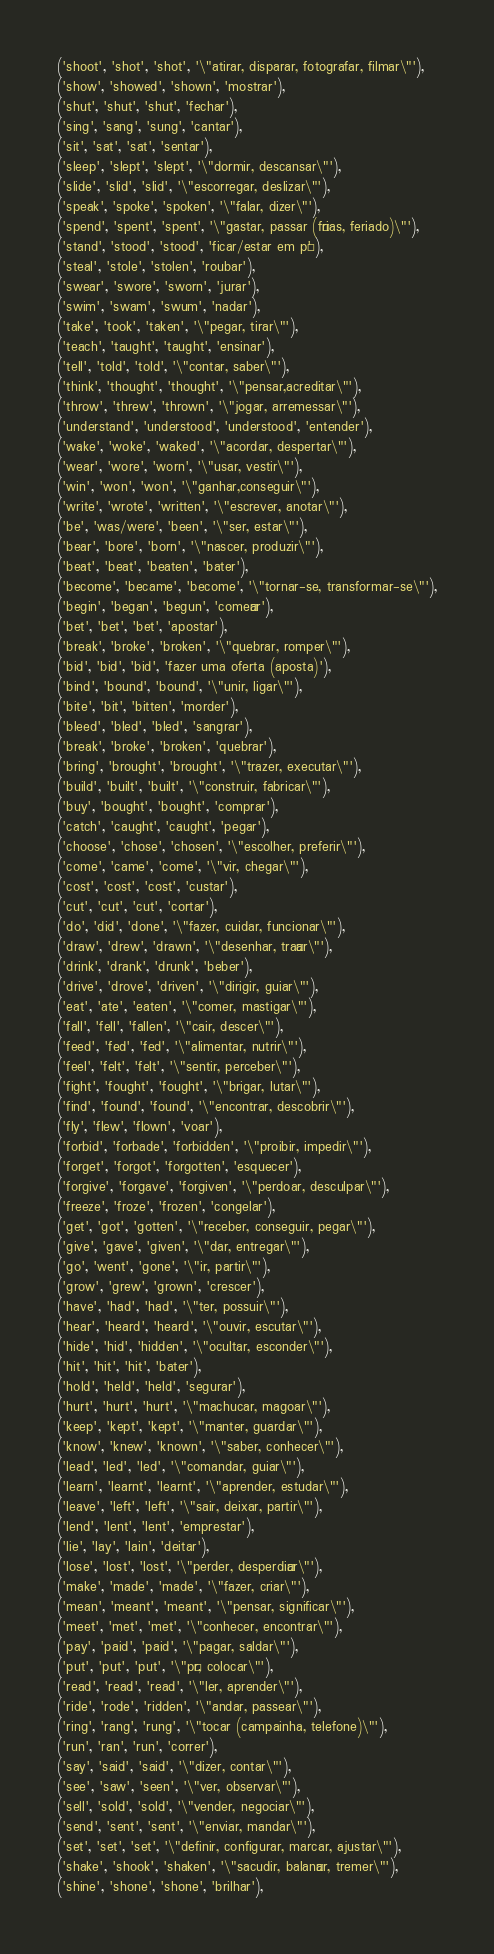<code> <loc_0><loc_0><loc_500><loc_500><_SQL_>('shoot', 'shot', 'shot', '\"atirar, disparar, fotografar, filmar\"'),
('show', 'showed', 'shown', 'mostrar'),
('shut', 'shut', 'shut', 'fechar'),
('sing', 'sang', 'sung', 'cantar'),
('sit', 'sat', 'sat', 'sentar'),
('sleep', 'slept', 'slept', '\"dormir, descansar\"'),
('slide', 'slid', 'slid', '\"escorregar, deslizar\"'),
('speak', 'spoke', 'spoken', '\"falar, dizer\"'),
('spend', 'spent', 'spent', '\"gastar, passar (férias, feriado)\"'),
('stand', 'stood', 'stood', 'ficar/estar em pé'),
('steal', 'stole', 'stolen', 'roubar'),
('swear', 'swore', 'sworn', 'jurar'),
('swim', 'swam', 'swum', 'nadar'),
('take', 'took', 'taken', '\"pegar, tirar\"'),
('teach', 'taught', 'taught', 'ensinar'),
('tell', 'told', 'told', '\"contar, saber\"'),
('think', 'thought', 'thought', '\"pensar,acreditar\"'),
('throw', 'threw', 'thrown', '\"jogar, arremessar\"'),
('understand', 'understood', 'understood', 'entender'),
('wake', 'woke', 'waked', '\"acordar, despertar\"'),
('wear', 'wore', 'worn', '\"usar, vestir\"'),
('win', 'won', 'won', '\"ganhar,conseguir\"'),
('write', 'wrote', 'written', '\"escrever, anotar\"'),
('be', 'was/were', 'been', '\"ser, estar\"'),
('bear', 'bore', 'born', '\"nascer, produzir\"'),
('beat', 'beat', 'beaten', 'bater'),
('become', 'became', 'become', '\"tornar-se, transformar-se\"'),
('begin', 'began', 'begun', 'começar'),
('bet', 'bet', 'bet', 'apostar'),
('break', 'broke', 'broken', '\"quebrar, romper\"'),
('bid', 'bid', 'bid', 'fazer uma oferta (aposta)'),
('bind', 'bound', 'bound', '\"unir, ligar\"'),
('bite', 'bit', 'bitten', 'morder'),
('bleed', 'bled', 'bled', 'sangrar'),
('break', 'broke', 'broken', 'quebrar'),
('bring', 'brought', 'brought', '\"trazer, executar\"'),
('build', 'built', 'built', '\"construir, fabricar\"'),
('buy', 'bought', 'bought', 'comprar'),
('catch', 'caught', 'caught', 'pegar'),
('choose', 'chose', 'chosen', '\"escolher, preferir\"'),
('come', 'came', 'come', '\"vir, chegar\"'),
('cost', 'cost', 'cost', 'custar'),
('cut', 'cut', 'cut', 'cortar'),
('do', 'did', 'done', '\"fazer, cuidar, funcionar\"'),
('draw', 'drew', 'drawn', '\"desenhar, traçar\"'),
('drink', 'drank', 'drunk', 'beber'),
('drive', 'drove', 'driven', '\"dirigir, guiar\"'),
('eat', 'ate', 'eaten', '\"comer, mastigar\"'),
('fall', 'fell', 'fallen', '\"cair, descer\"'),
('feed', 'fed', 'fed', '\"alimentar, nutrir\"'),
('feel', 'felt', 'felt', '\"sentir, perceber\"'),
('fight', 'fought', 'fought', '\"brigar, lutar\"'),
('find', 'found', 'found', '\"encontrar, descobrir\"'),
('fly', 'flew', 'flown', 'voar'),
('forbid', 'forbade', 'forbidden', '\"proibir, impedir\"'),
('forget', 'forgot', 'forgotten', 'esquecer'),
('forgive', 'forgave', 'forgiven', '\"perdoar, desculpar\"'),
('freeze', 'froze', 'frozen', 'congelar'),
('get', 'got', 'gotten', '\"receber, conseguir, pegar\"'),
('give', 'gave', 'given', '\"dar, entregar\"'),
('go', 'went', 'gone', '\"ir, partir\"'),
('grow', 'grew', 'grown', 'crescer'),
('have', 'had', 'had', '\"ter, possuir\"'),
('hear', 'heard', 'heard', '\"ouvir, escutar\"'),
('hide', 'hid', 'hidden', '\"ocultar, esconder\"'),
('hit', 'hit', 'hit', 'bater'),
('hold', 'held', 'held', 'segurar'),
('hurt', 'hurt', 'hurt', '\"machucar, magoar\"'),
('keep', 'kept', 'kept', '\"manter, guardar\"'),
('know', 'knew', 'known', '\"saber, conhecer\"'),
('lead', 'led', 'led', '\"comandar, guiar\"'),
('learn', 'learnt', 'learnt', '\"aprender, estudar\"'),
('leave', 'left', 'left', '\"sair, deixar, partir\"'),
('lend', 'lent', 'lent', 'emprestar'),
('lie', 'lay', 'lain', 'deitar'),
('lose', 'lost', 'lost', '\"perder, desperdiçar\"'),
('make', 'made', 'made', '\"fazer, criar\"'),
('mean', 'meant', 'meant', '\"pensar, significar\"'),
('meet', 'met', 'met', '\"conhecer, encontrar\"'),
('pay', 'paid', 'paid', '\"pagar, saldar\"'),
('put', 'put', 'put', '\"pôr, colocar\"'),
('read', 'read', 'read', '\"ler, aprender\"'),
('ride', 'rode', 'ridden', '\"andar, passear\"'),
('ring', 'rang', 'rung', '\"tocar (campainha, telefone)\"'),
('run', 'ran', 'run', 'correr'),
('say', 'said', 'said', '\"dizer, contar\"'),
('see', 'saw', 'seen', '\"ver, observar\"'),
('sell', 'sold', 'sold', '\"vender, negociar\"'),
('send', 'sent', 'sent', '\"enviar, mandar\"'),
('set', 'set', 'set', '\"definir, configurar, marcar, ajustar\"'),
('shake', 'shook', 'shaken', '\"sacudir, balançar, tremer\"'),
('shine', 'shone', 'shone', 'brilhar'),</code> 